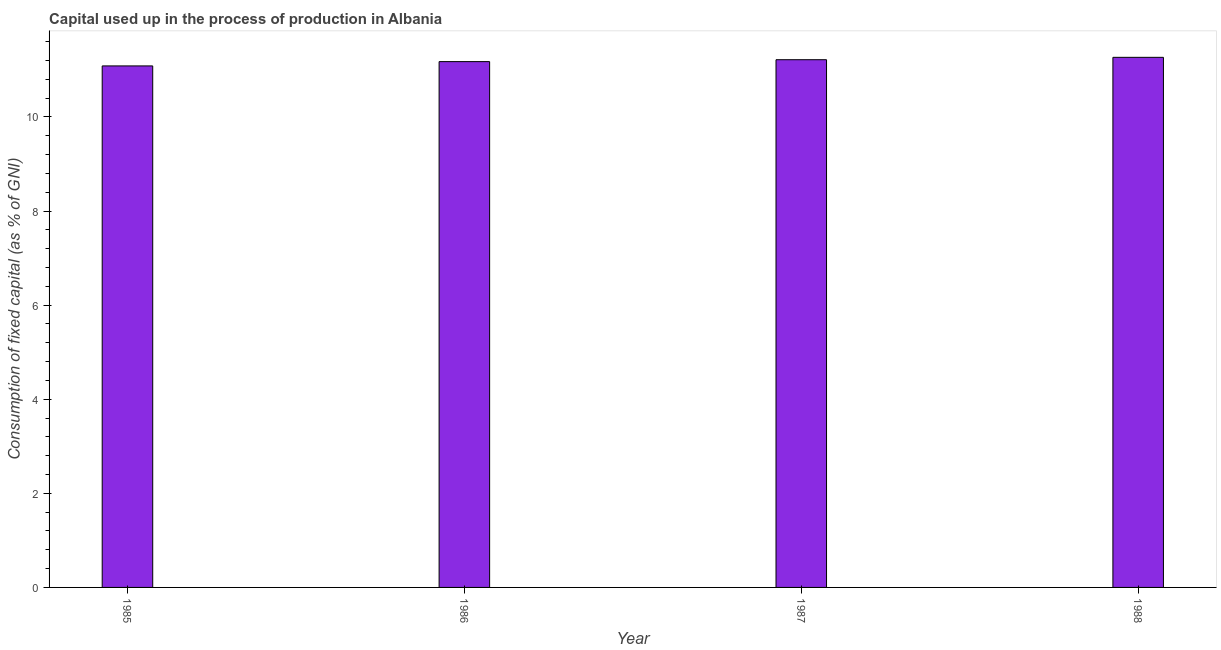What is the title of the graph?
Keep it short and to the point. Capital used up in the process of production in Albania. What is the label or title of the Y-axis?
Your answer should be very brief. Consumption of fixed capital (as % of GNI). What is the consumption of fixed capital in 1986?
Provide a succinct answer. 11.18. Across all years, what is the maximum consumption of fixed capital?
Offer a very short reply. 11.27. Across all years, what is the minimum consumption of fixed capital?
Your answer should be compact. 11.08. In which year was the consumption of fixed capital maximum?
Ensure brevity in your answer.  1988. What is the sum of the consumption of fixed capital?
Your response must be concise. 44.74. What is the difference between the consumption of fixed capital in 1986 and 1988?
Provide a short and direct response. -0.09. What is the average consumption of fixed capital per year?
Provide a short and direct response. 11.19. What is the median consumption of fixed capital?
Ensure brevity in your answer.  11.2. In how many years, is the consumption of fixed capital greater than 10.8 %?
Your response must be concise. 4. Do a majority of the years between 1986 and 1988 (inclusive) have consumption of fixed capital greater than 2.8 %?
Offer a very short reply. Yes. What is the ratio of the consumption of fixed capital in 1985 to that in 1988?
Give a very brief answer. 0.98. Is the difference between the consumption of fixed capital in 1985 and 1987 greater than the difference between any two years?
Make the answer very short. No. What is the difference between the highest and the second highest consumption of fixed capital?
Provide a short and direct response. 0.05. What is the difference between the highest and the lowest consumption of fixed capital?
Give a very brief answer. 0.18. Are all the bars in the graph horizontal?
Give a very brief answer. No. What is the difference between two consecutive major ticks on the Y-axis?
Offer a very short reply. 2. What is the Consumption of fixed capital (as % of GNI) of 1985?
Ensure brevity in your answer.  11.08. What is the Consumption of fixed capital (as % of GNI) of 1986?
Give a very brief answer. 11.18. What is the Consumption of fixed capital (as % of GNI) of 1987?
Your answer should be very brief. 11.22. What is the Consumption of fixed capital (as % of GNI) in 1988?
Give a very brief answer. 11.27. What is the difference between the Consumption of fixed capital (as % of GNI) in 1985 and 1986?
Provide a succinct answer. -0.09. What is the difference between the Consumption of fixed capital (as % of GNI) in 1985 and 1987?
Offer a terse response. -0.13. What is the difference between the Consumption of fixed capital (as % of GNI) in 1985 and 1988?
Make the answer very short. -0.18. What is the difference between the Consumption of fixed capital (as % of GNI) in 1986 and 1987?
Offer a very short reply. -0.04. What is the difference between the Consumption of fixed capital (as % of GNI) in 1986 and 1988?
Offer a very short reply. -0.09. What is the difference between the Consumption of fixed capital (as % of GNI) in 1987 and 1988?
Your response must be concise. -0.05. What is the ratio of the Consumption of fixed capital (as % of GNI) in 1985 to that in 1986?
Provide a succinct answer. 0.99. What is the ratio of the Consumption of fixed capital (as % of GNI) in 1985 to that in 1987?
Provide a succinct answer. 0.99. 